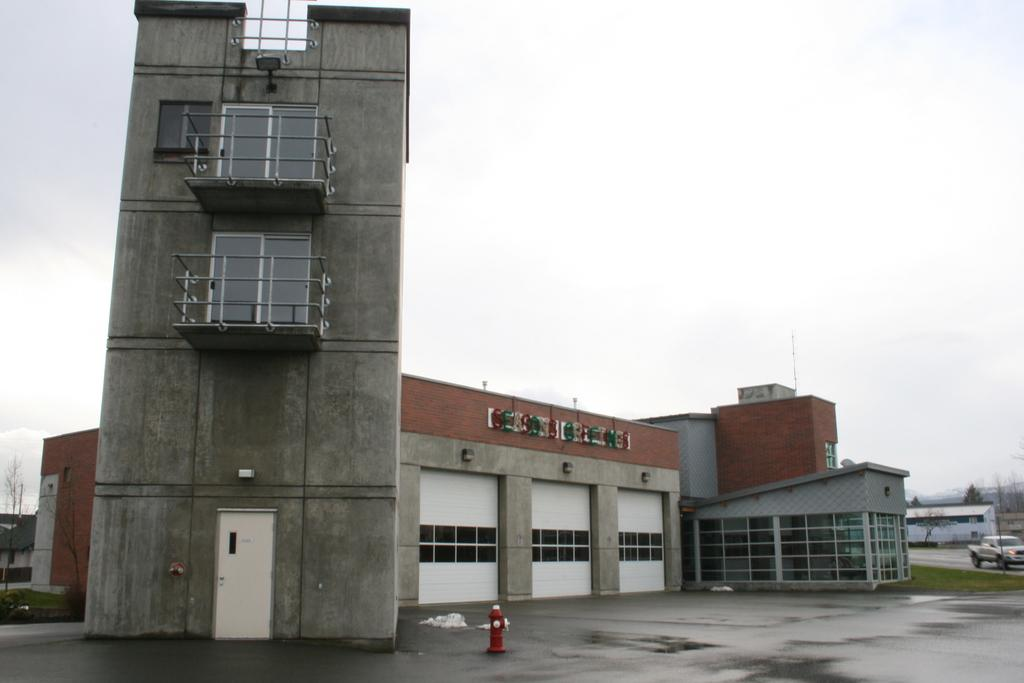What is the main object in the image? There is a fire hydrant in the image. What type of structure can be seen in the image? There is a building with windows in the image. What is the purpose of the light board in the image? The purpose of the light board in the image is to display information or advertisements. What is the entrance to the building in the image? There is a door in the image. What type of security feature is present in the image? There are iron grills in the image. What type of vehicle is present in the image? There is a truck in the image. What type of vegetation is present in the image? There is grass, plants, and trees in the image. What is visible in the background of the image? The sky is visible in the image. What is the opinion of the fire hydrant about the truck in the image? Fire hydrants do not have opinions, as they are inanimate objects. 